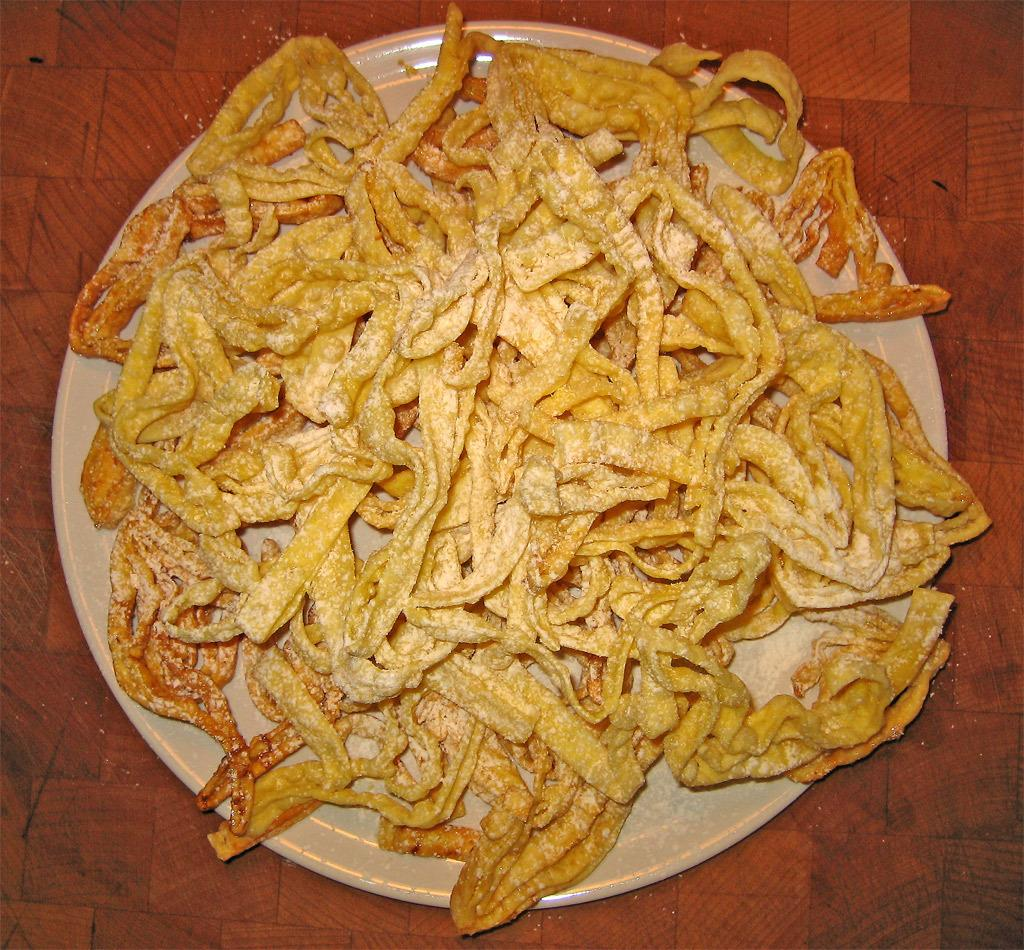What is on the plate in the image? There are food items on the plate in the image. Where is the plate located? The plate is placed on the floor. What time does the clock on the plate indicate in the image? There is no clock present on the plate in the image. 